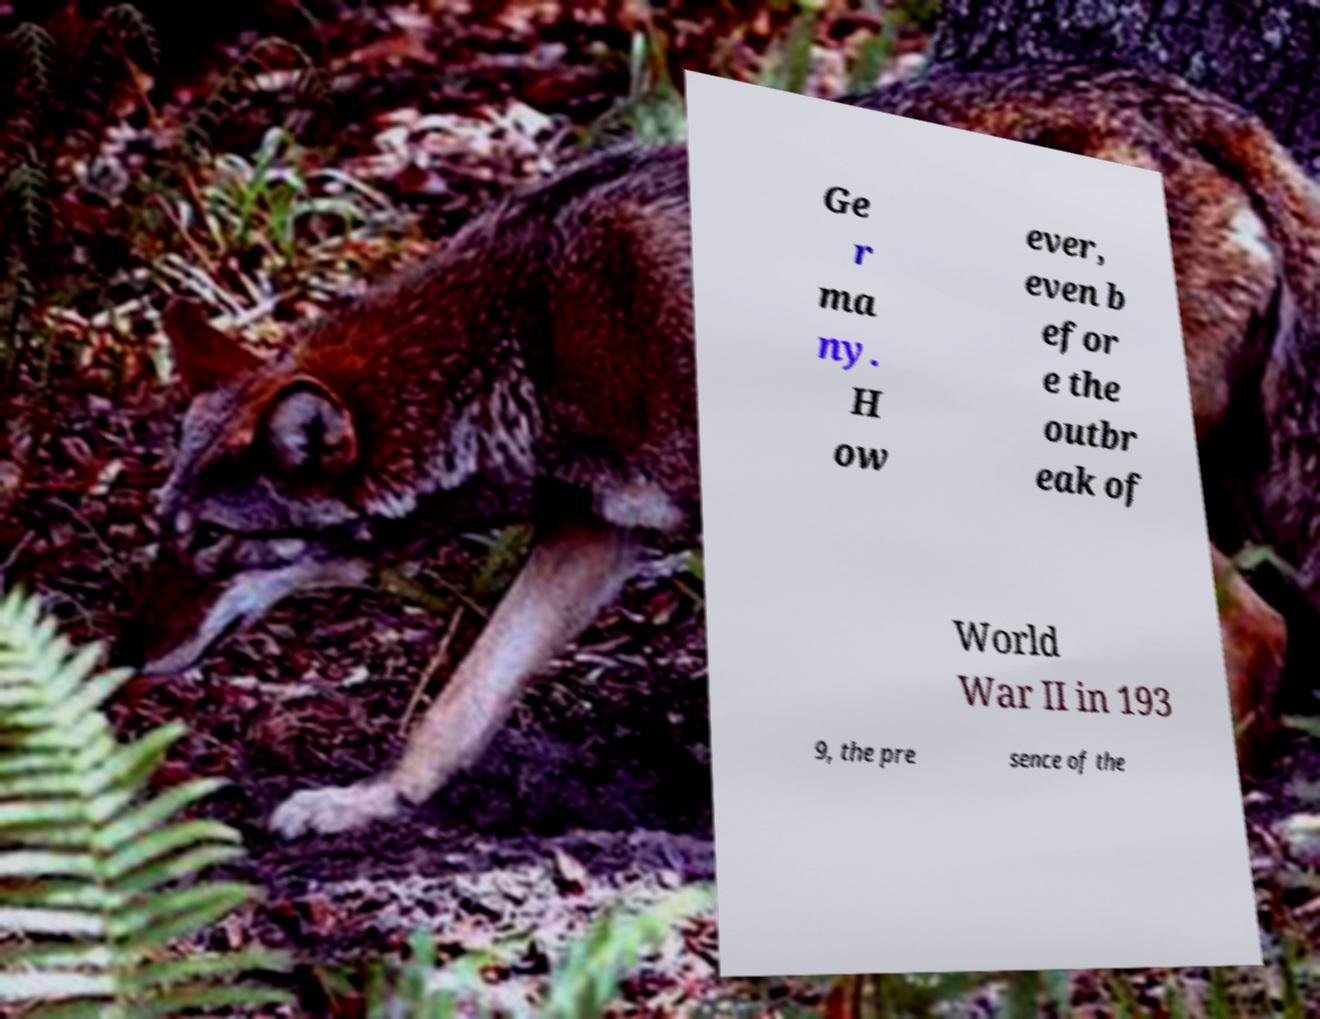Can you accurately transcribe the text from the provided image for me? Ge r ma ny. H ow ever, even b efor e the outbr eak of World War II in 193 9, the pre sence of the 